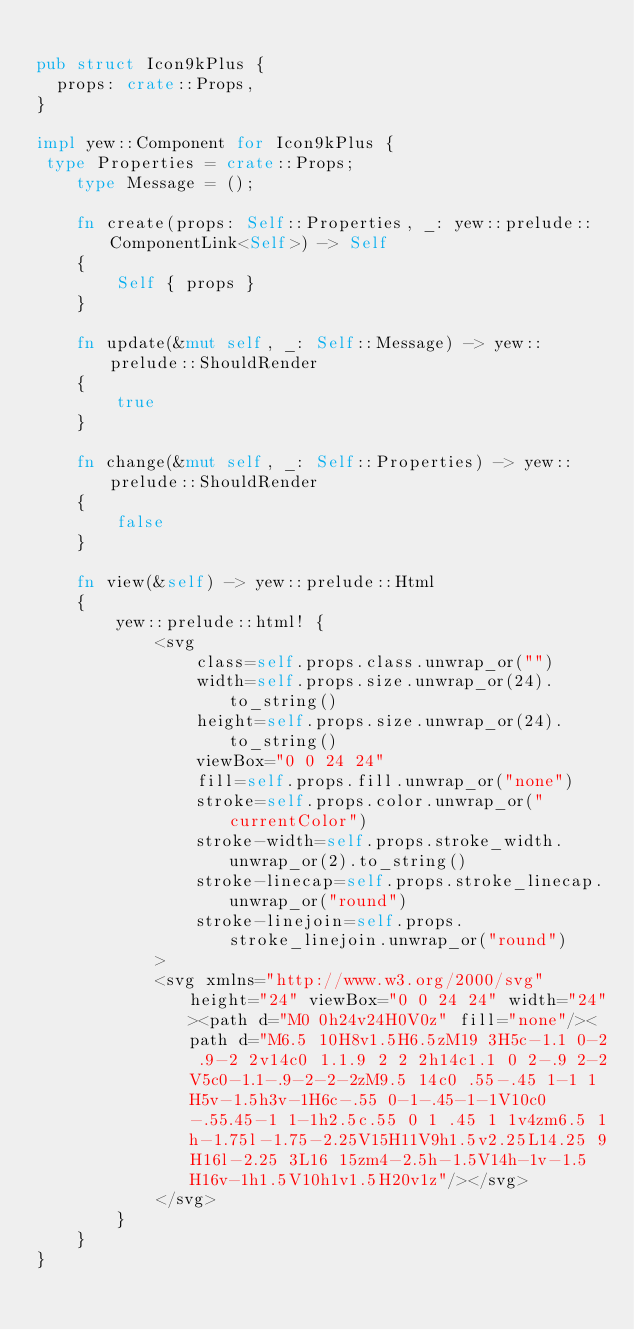<code> <loc_0><loc_0><loc_500><loc_500><_Rust_>
pub struct Icon9kPlus {
  props: crate::Props,
}

impl yew::Component for Icon9kPlus {
 type Properties = crate::Props;
    type Message = ();

    fn create(props: Self::Properties, _: yew::prelude::ComponentLink<Self>) -> Self
    {
        Self { props }
    }

    fn update(&mut self, _: Self::Message) -> yew::prelude::ShouldRender
    {
        true
    }

    fn change(&mut self, _: Self::Properties) -> yew::prelude::ShouldRender
    {
        false
    }

    fn view(&self) -> yew::prelude::Html
    {
        yew::prelude::html! {
            <svg
                class=self.props.class.unwrap_or("")
                width=self.props.size.unwrap_or(24).to_string()
                height=self.props.size.unwrap_or(24).to_string()
                viewBox="0 0 24 24"
                fill=self.props.fill.unwrap_or("none")
                stroke=self.props.color.unwrap_or("currentColor")
                stroke-width=self.props.stroke_width.unwrap_or(2).to_string()
                stroke-linecap=self.props.stroke_linecap.unwrap_or("round")
                stroke-linejoin=self.props.stroke_linejoin.unwrap_or("round")
            >
            <svg xmlns="http://www.w3.org/2000/svg" height="24" viewBox="0 0 24 24" width="24"><path d="M0 0h24v24H0V0z" fill="none"/><path d="M6.5 10H8v1.5H6.5zM19 3H5c-1.1 0-2 .9-2 2v14c0 1.1.9 2 2 2h14c1.1 0 2-.9 2-2V5c0-1.1-.9-2-2-2zM9.5 14c0 .55-.45 1-1 1H5v-1.5h3v-1H6c-.55 0-1-.45-1-1V10c0-.55.45-1 1-1h2.5c.55 0 1 .45 1 1v4zm6.5 1h-1.75l-1.75-2.25V15H11V9h1.5v2.25L14.25 9H16l-2.25 3L16 15zm4-2.5h-1.5V14h-1v-1.5H16v-1h1.5V10h1v1.5H20v1z"/></svg>
            </svg>
        }
    }
}


</code> 